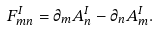<formula> <loc_0><loc_0><loc_500><loc_500>F _ { m n } ^ { I } = \partial _ { m } A _ { n } ^ { I } - \partial _ { n } A _ { m } ^ { I } .</formula> 